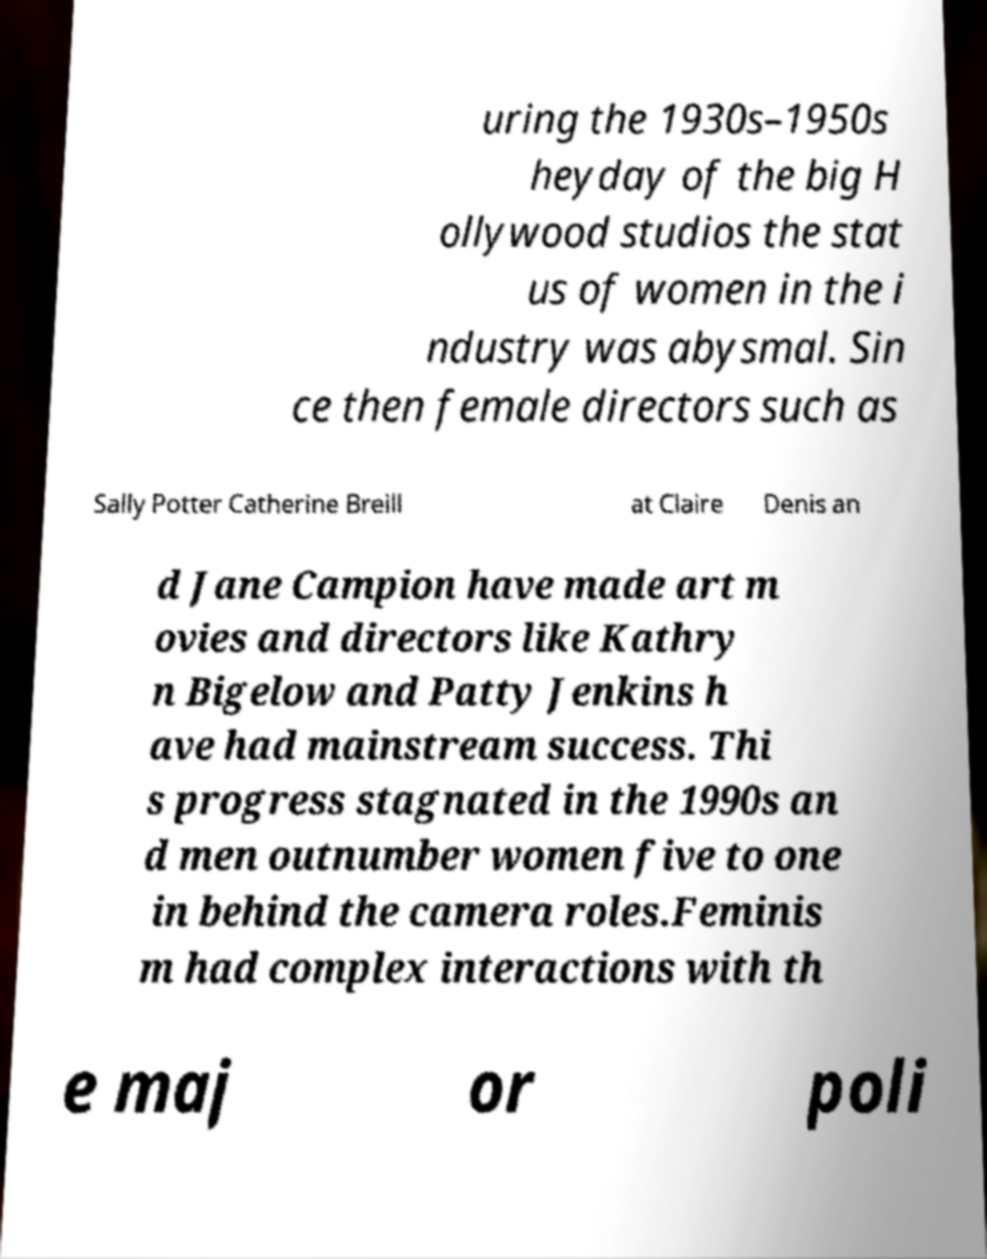What messages or text are displayed in this image? I need them in a readable, typed format. uring the 1930s–1950s heyday of the big H ollywood studios the stat us of women in the i ndustry was abysmal. Sin ce then female directors such as Sally Potter Catherine Breill at Claire Denis an d Jane Campion have made art m ovies and directors like Kathry n Bigelow and Patty Jenkins h ave had mainstream success. Thi s progress stagnated in the 1990s an d men outnumber women five to one in behind the camera roles.Feminis m had complex interactions with th e maj or poli 